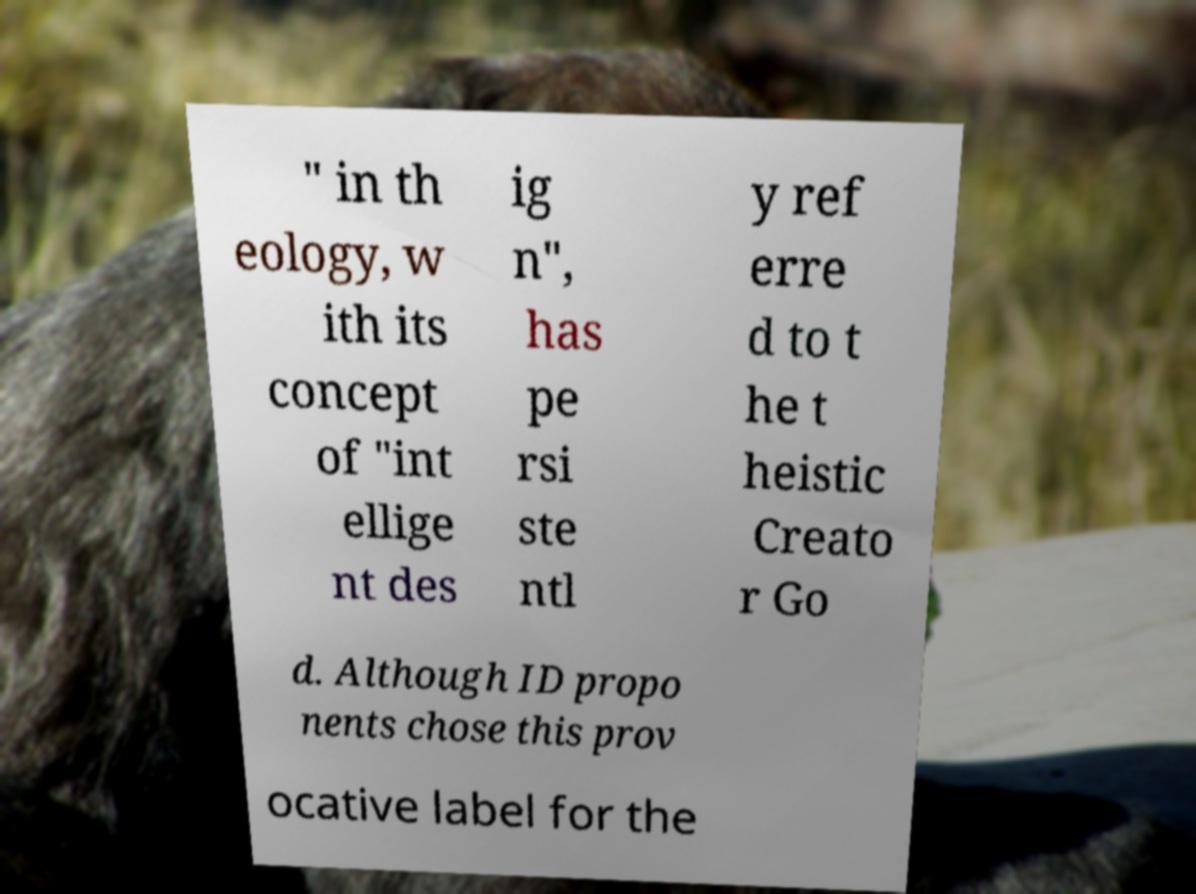Please identify and transcribe the text found in this image. " in th eology, w ith its concept of "int ellige nt des ig n", has pe rsi ste ntl y ref erre d to t he t heistic Creato r Go d. Although ID propo nents chose this prov ocative label for the 